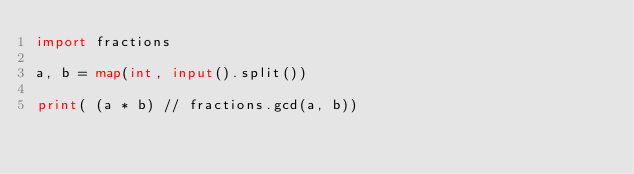Convert code to text. <code><loc_0><loc_0><loc_500><loc_500><_Python_>import fractions

a, b = map(int, input().split())

print( (a * b) // fractions.gcd(a, b))</code> 